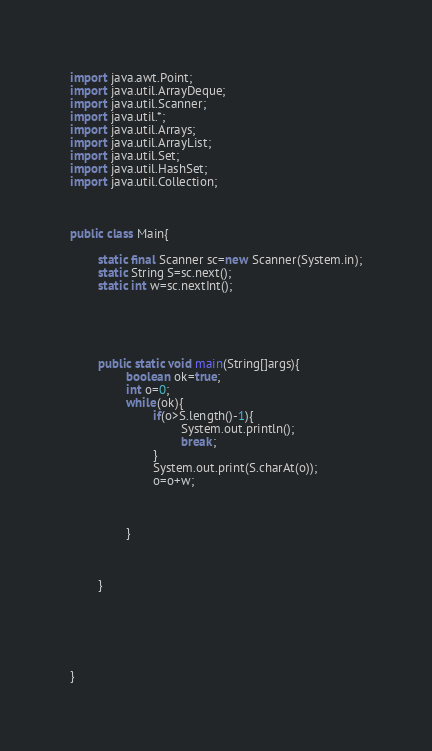<code> <loc_0><loc_0><loc_500><loc_500><_Java_>import java.awt.Point;
import java.util.ArrayDeque;
import java.util.Scanner;
import java.util.*;
import java.util.Arrays;
import java.util.ArrayList;
import java.util.Set;
import java.util.HashSet;
import java.util.Collection;


 
public class Main{
	
        static final Scanner sc=new Scanner(System.in);
        static String S=sc.next();
        static int w=sc.nextInt();
        
        
        
        
        
        public static void main(String[]args){
                boolean ok=true;
                int o=0;
                while(ok){
                        if(o>S.length()-1){
                                System.out.println();
                                break;
                        }
                        System.out.print(S.charAt(o));
                        o=o+w;



                }
                
                

        }
        
        
        

		
	
}
</code> 